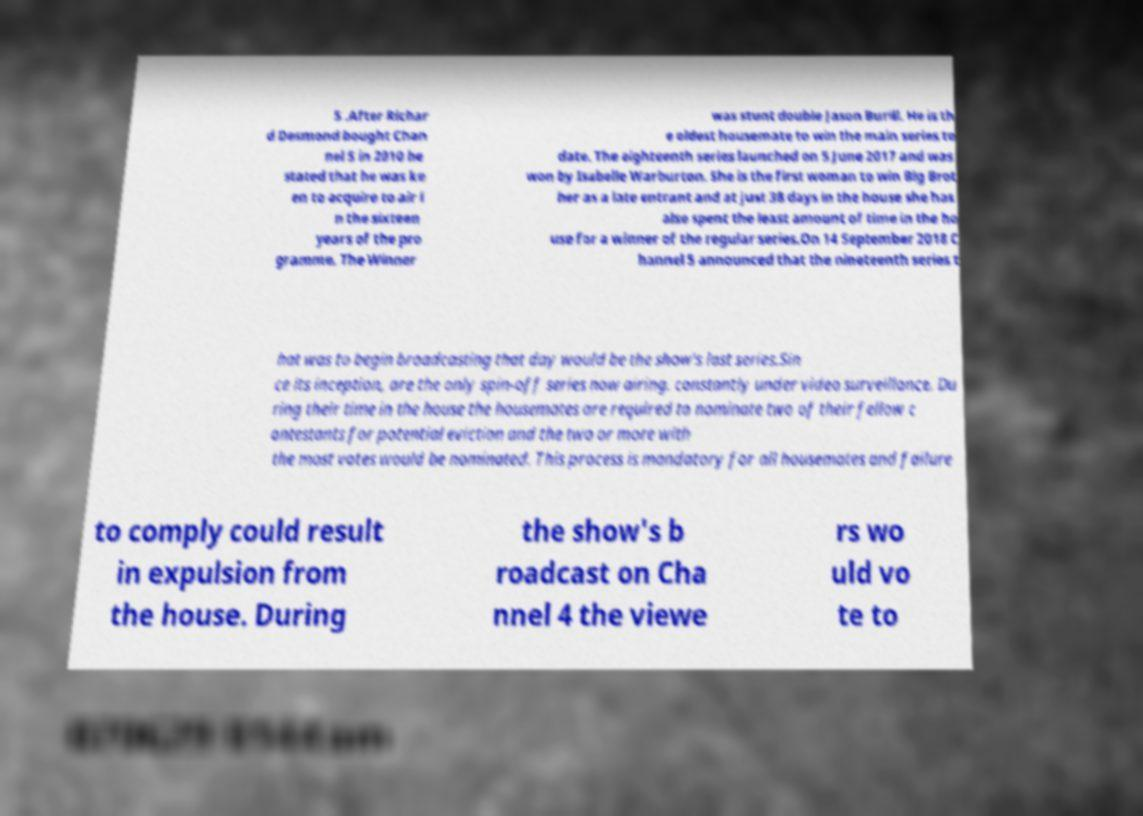There's text embedded in this image that I need extracted. Can you transcribe it verbatim? 5 .After Richar d Desmond bought Chan nel 5 in 2010 he stated that he was ke en to acquire to air i n the sixteen years of the pro gramme. The Winner was stunt double Jason Burill. He is th e oldest housemate to win the main series to date. The eighteenth series launched on 5 June 2017 and was won by Isabelle Warburton. She is the first woman to win Big Brot her as a late entrant and at just 38 days in the house she has also spent the least amount of time in the ho use for a winner of the regular series.On 14 September 2018 C hannel 5 announced that the nineteenth series t hat was to begin broadcasting that day would be the show's last series.Sin ce its inception, are the only spin-off series now airing. constantly under video surveillance. Du ring their time in the house the housemates are required to nominate two of their fellow c ontestants for potential eviction and the two or more with the most votes would be nominated. This process is mandatory for all housemates and failure to comply could result in expulsion from the house. During the show's b roadcast on Cha nnel 4 the viewe rs wo uld vo te to 